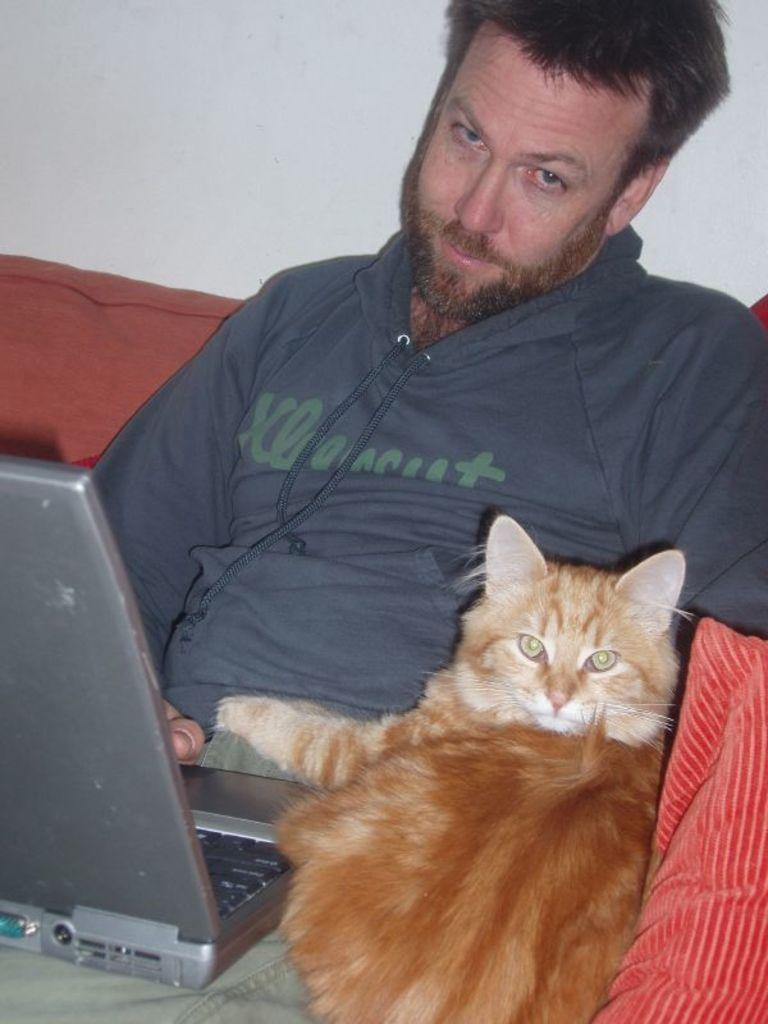What piece of furniture is in the image? There is a couch in the image. Who or what is on the couch? A person is sitting on the couch, and there is a cat on the couch as well. What is the person holding? The person is holding a laptop. What is on the couch that provides comfort or decoration? There is a pillow on the couch. What color is the wall in the background? The wall in the background is painted white. What type of crime is being committed in the image? There is no crime being committed in the image; it shows a person sitting on a couch with a cat and a laptop. What board game is being played on the couch? There is no board game present in the image. 